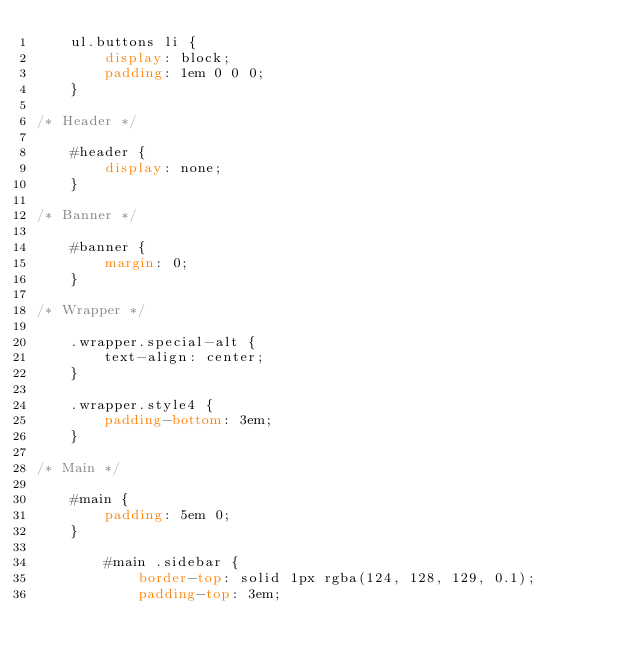<code> <loc_0><loc_0><loc_500><loc_500><_CSS_>	ul.buttons li {
		display: block;
		padding: 1em 0 0 0;
	}

/* Header */

	#header {
		display: none;
	}

/* Banner */

	#banner {
		margin: 0;
	}

/* Wrapper */

	.wrapper.special-alt {
		text-align: center;
	}

	.wrapper.style4 {
		padding-bottom: 3em;
	}

/* Main */

	#main {
		padding: 5em 0;
	}

		#main .sidebar {
			border-top: solid 1px rgba(124, 128, 129, 0.1);
			padding-top: 3em;</code> 